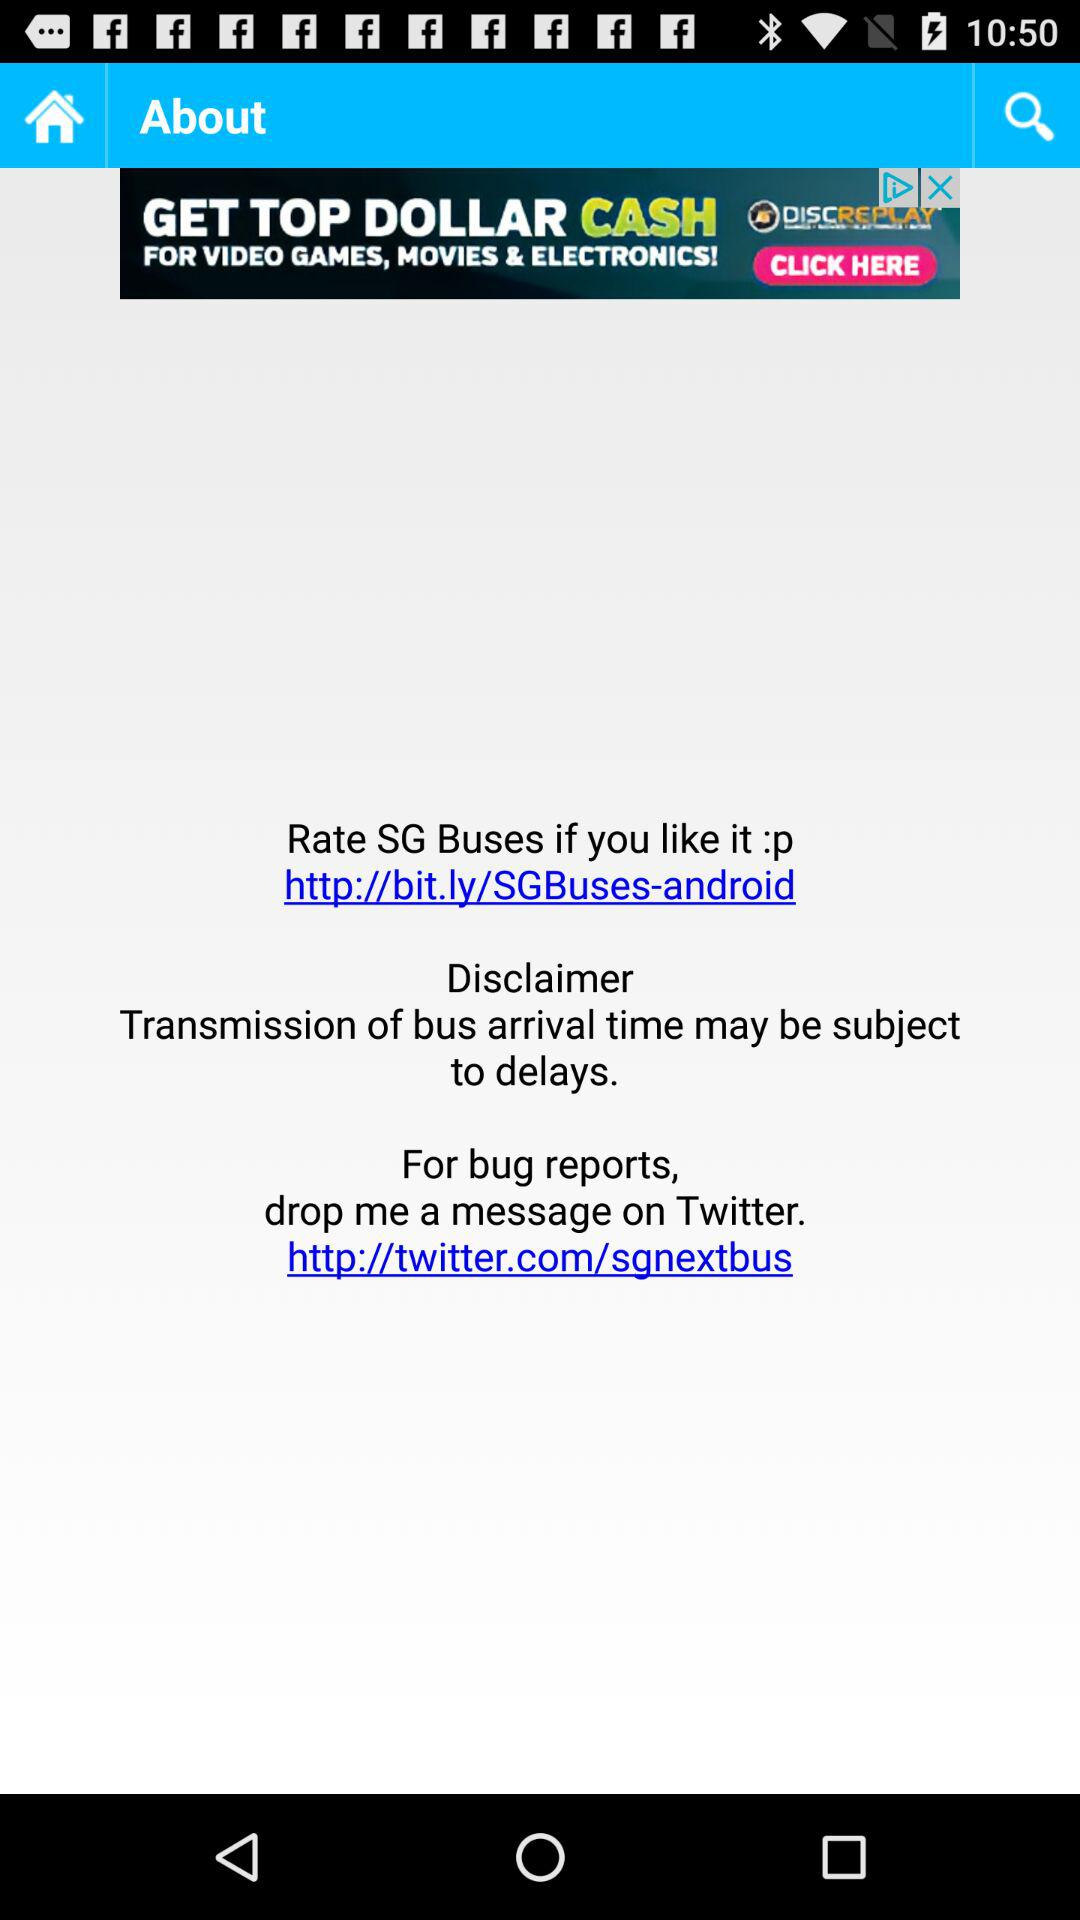What's the "Twitter" hyperlink for bug reports? The "Twitter" hyperlink for bug reports is http://twitter.com/sgnextbus. 